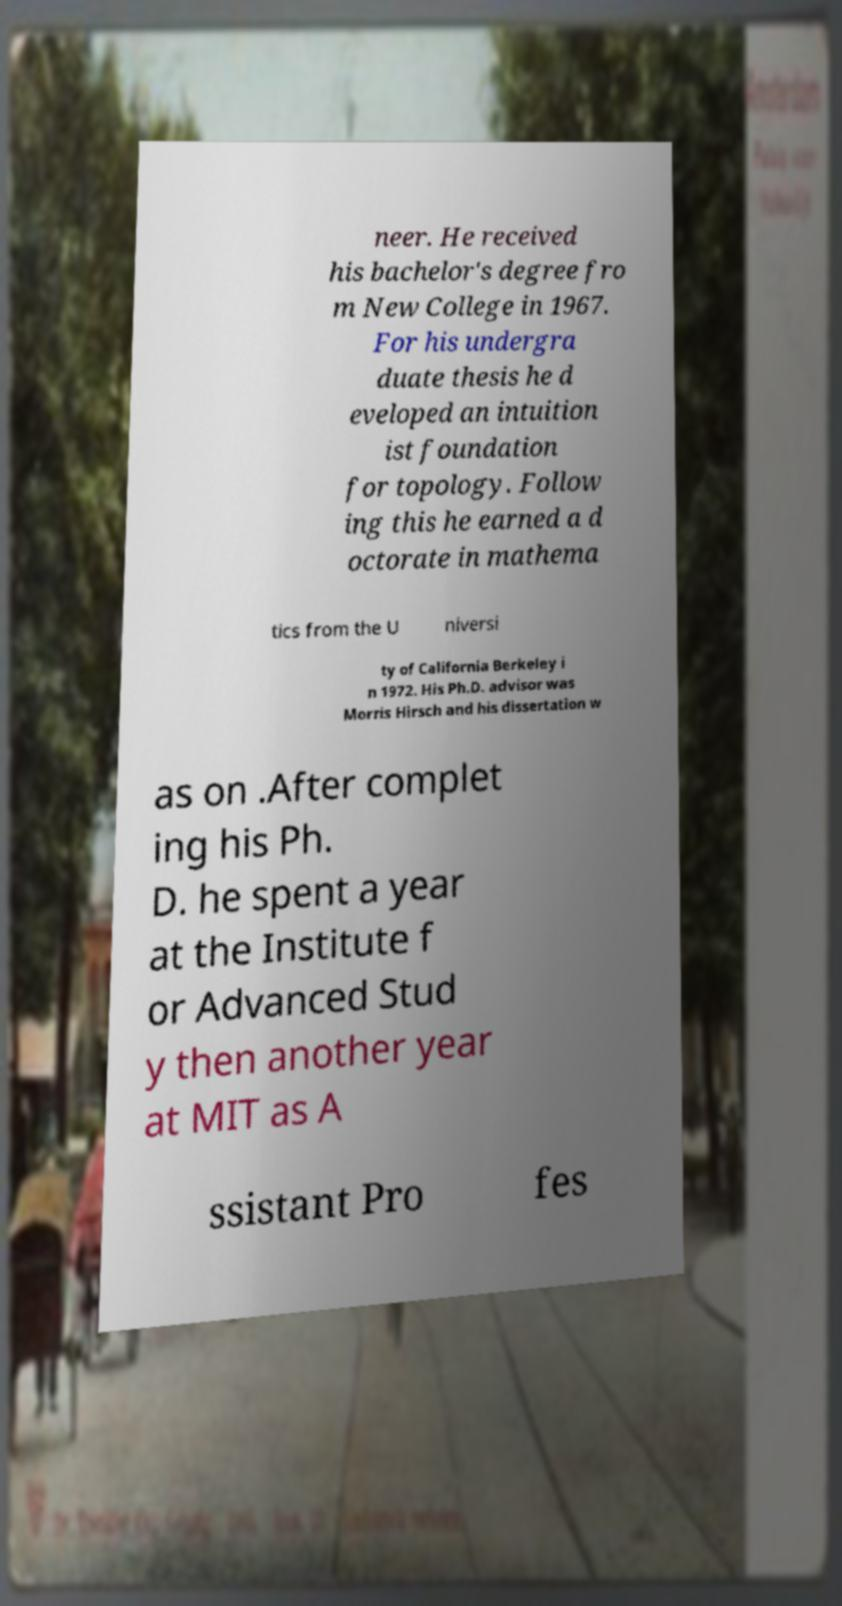I need the written content from this picture converted into text. Can you do that? neer. He received his bachelor's degree fro m New College in 1967. For his undergra duate thesis he d eveloped an intuition ist foundation for topology. Follow ing this he earned a d octorate in mathema tics from the U niversi ty of California Berkeley i n 1972. His Ph.D. advisor was Morris Hirsch and his dissertation w as on .After complet ing his Ph. D. he spent a year at the Institute f or Advanced Stud y then another year at MIT as A ssistant Pro fes 